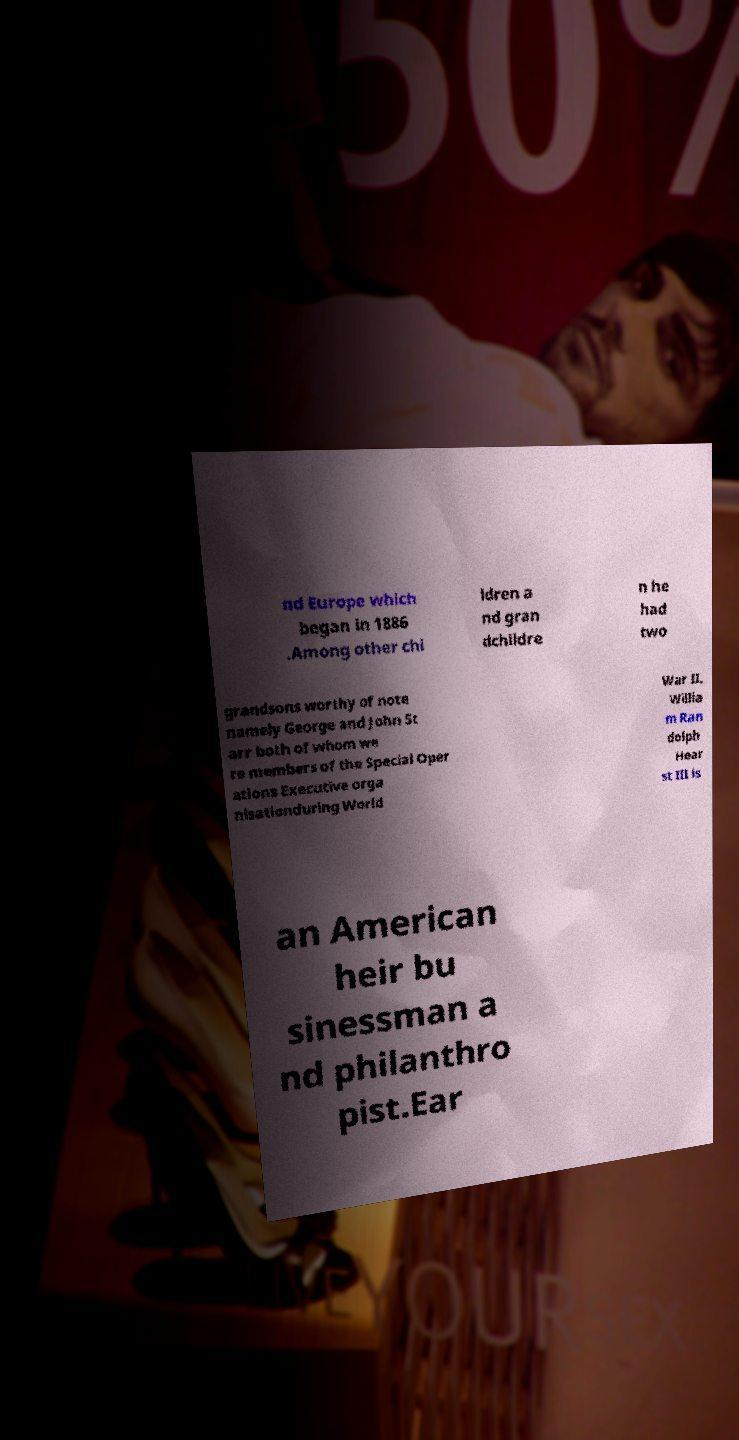Can you accurately transcribe the text from the provided image for me? nd Europe which began in 1886 .Among other chi ldren a nd gran dchildre n he had two grandsons worthy of note namely George and John St arr both of whom we re members of the Special Oper ations Executive orga nisationduring World War II. Willia m Ran dolph Hear st III is an American heir bu sinessman a nd philanthro pist.Ear 